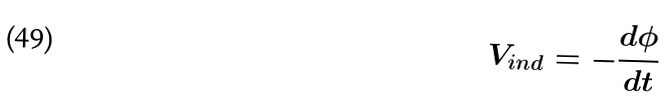Convert formula to latex. <formula><loc_0><loc_0><loc_500><loc_500>V _ { i n d } = - \frac { d \phi } { d t }</formula> 